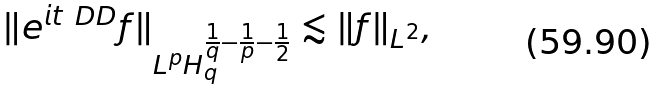<formula> <loc_0><loc_0><loc_500><loc_500>\| e ^ { i t \ D D } f \| _ { L ^ { p } H ^ { \frac { 1 } { q } - \frac { 1 } { p } - \frac { 1 } { 2 } } _ { q } } \lesssim \| f \| _ { L ^ { 2 } } ,</formula> 